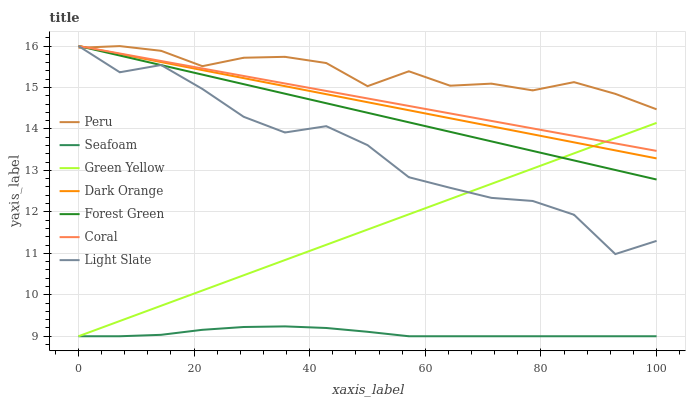Does Seafoam have the minimum area under the curve?
Answer yes or no. Yes. Does Peru have the maximum area under the curve?
Answer yes or no. Yes. Does Light Slate have the minimum area under the curve?
Answer yes or no. No. Does Light Slate have the maximum area under the curve?
Answer yes or no. No. Is Dark Orange the smoothest?
Answer yes or no. Yes. Is Light Slate the roughest?
Answer yes or no. Yes. Is Coral the smoothest?
Answer yes or no. No. Is Coral the roughest?
Answer yes or no. No. Does Seafoam have the lowest value?
Answer yes or no. Yes. Does Light Slate have the lowest value?
Answer yes or no. No. Does Forest Green have the highest value?
Answer yes or no. Yes. Does Seafoam have the highest value?
Answer yes or no. No. Is Seafoam less than Light Slate?
Answer yes or no. Yes. Is Forest Green greater than Seafoam?
Answer yes or no. Yes. Does Dark Orange intersect Coral?
Answer yes or no. Yes. Is Dark Orange less than Coral?
Answer yes or no. No. Is Dark Orange greater than Coral?
Answer yes or no. No. Does Seafoam intersect Light Slate?
Answer yes or no. No. 